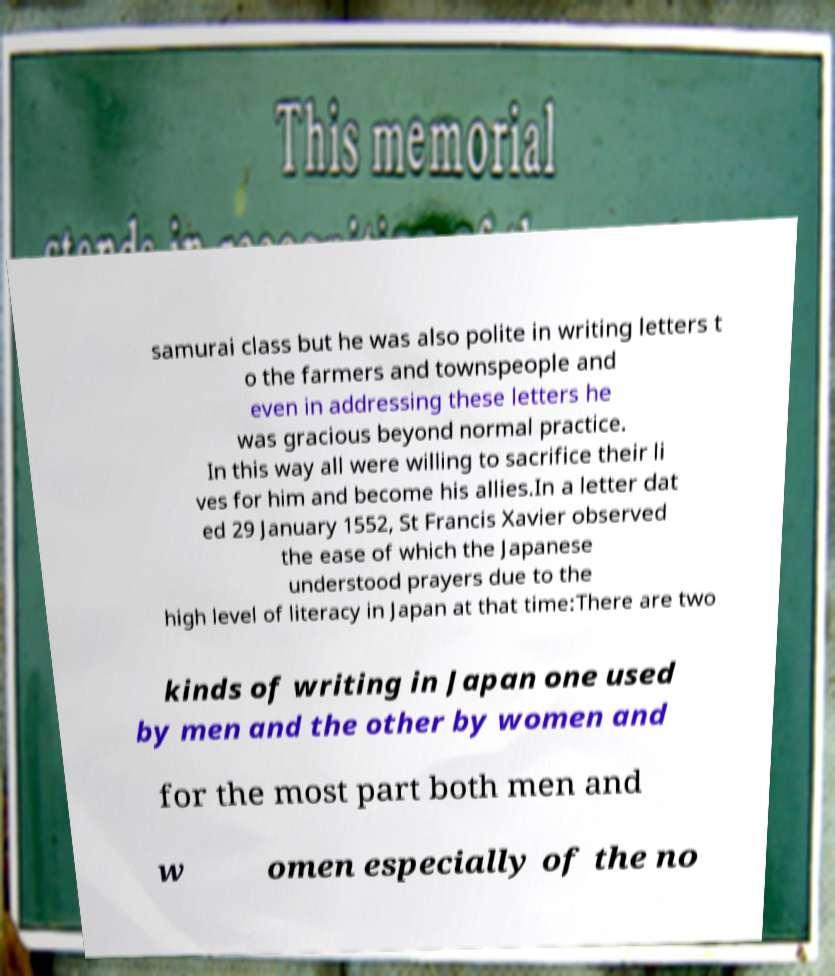Could you assist in decoding the text presented in this image and type it out clearly? samurai class but he was also polite in writing letters t o the farmers and townspeople and even in addressing these letters he was gracious beyond normal practice. In this way all were willing to sacrifice their li ves for him and become his allies.In a letter dat ed 29 January 1552, St Francis Xavier observed the ease of which the Japanese understood prayers due to the high level of literacy in Japan at that time:There are two kinds of writing in Japan one used by men and the other by women and for the most part both men and w omen especially of the no 